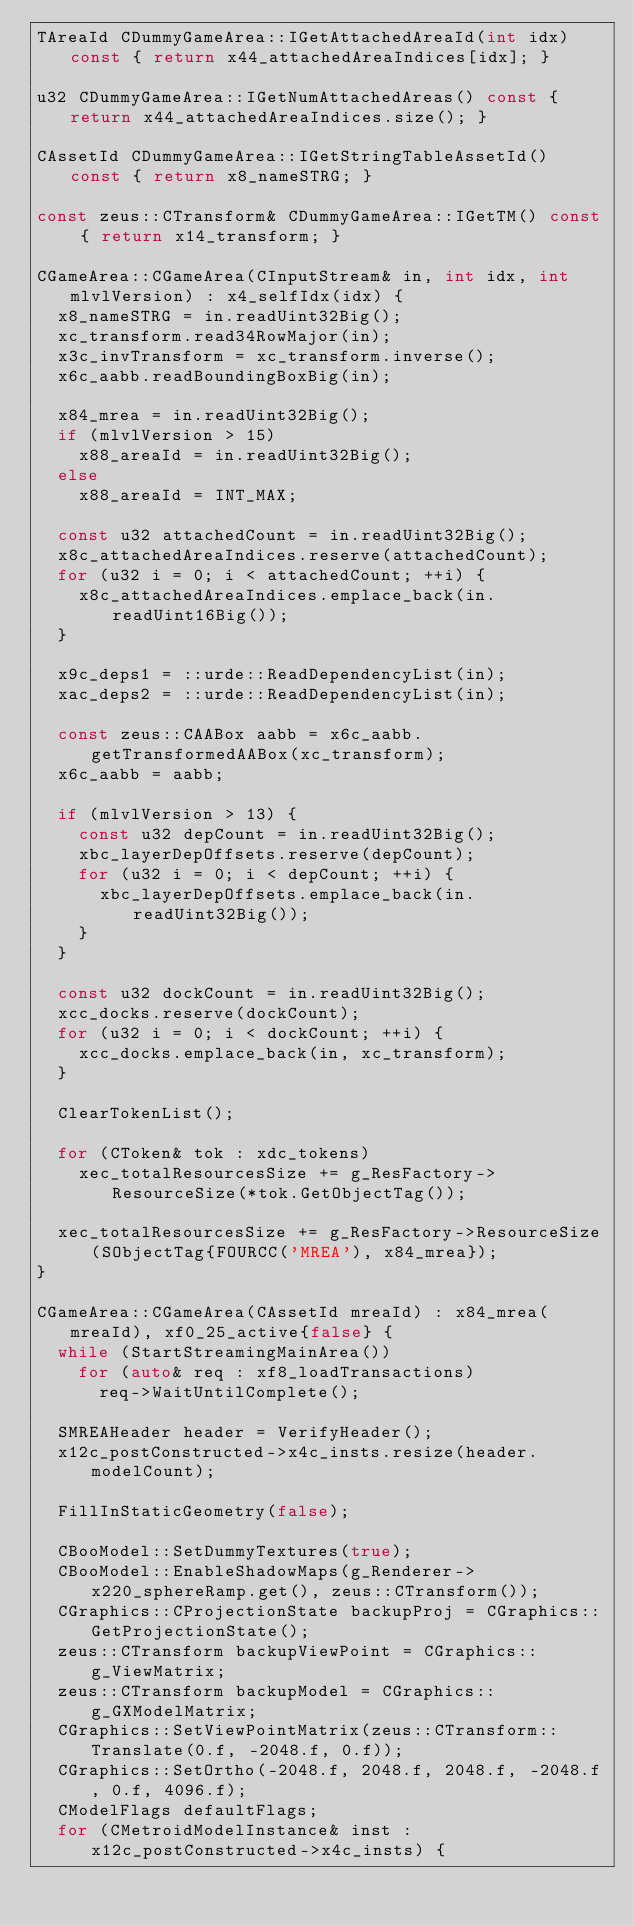Convert code to text. <code><loc_0><loc_0><loc_500><loc_500><_C++_>TAreaId CDummyGameArea::IGetAttachedAreaId(int idx) const { return x44_attachedAreaIndices[idx]; }

u32 CDummyGameArea::IGetNumAttachedAreas() const { return x44_attachedAreaIndices.size(); }

CAssetId CDummyGameArea::IGetStringTableAssetId() const { return x8_nameSTRG; }

const zeus::CTransform& CDummyGameArea::IGetTM() const { return x14_transform; }

CGameArea::CGameArea(CInputStream& in, int idx, int mlvlVersion) : x4_selfIdx(idx) {
  x8_nameSTRG = in.readUint32Big();
  xc_transform.read34RowMajor(in);
  x3c_invTransform = xc_transform.inverse();
  x6c_aabb.readBoundingBoxBig(in);

  x84_mrea = in.readUint32Big();
  if (mlvlVersion > 15)
    x88_areaId = in.readUint32Big();
  else
    x88_areaId = INT_MAX;

  const u32 attachedCount = in.readUint32Big();
  x8c_attachedAreaIndices.reserve(attachedCount);
  for (u32 i = 0; i < attachedCount; ++i) {
    x8c_attachedAreaIndices.emplace_back(in.readUint16Big());
  }

  x9c_deps1 = ::urde::ReadDependencyList(in);
  xac_deps2 = ::urde::ReadDependencyList(in);

  const zeus::CAABox aabb = x6c_aabb.getTransformedAABox(xc_transform);
  x6c_aabb = aabb;

  if (mlvlVersion > 13) {
    const u32 depCount = in.readUint32Big();
    xbc_layerDepOffsets.reserve(depCount);
    for (u32 i = 0; i < depCount; ++i) {
      xbc_layerDepOffsets.emplace_back(in.readUint32Big());
    }
  }

  const u32 dockCount = in.readUint32Big();
  xcc_docks.reserve(dockCount);
  for (u32 i = 0; i < dockCount; ++i) {
    xcc_docks.emplace_back(in, xc_transform);
  }

  ClearTokenList();

  for (CToken& tok : xdc_tokens)
    xec_totalResourcesSize += g_ResFactory->ResourceSize(*tok.GetObjectTag());

  xec_totalResourcesSize += g_ResFactory->ResourceSize(SObjectTag{FOURCC('MREA'), x84_mrea});
}

CGameArea::CGameArea(CAssetId mreaId) : x84_mrea(mreaId), xf0_25_active{false} {
  while (StartStreamingMainArea())
    for (auto& req : xf8_loadTransactions)
      req->WaitUntilComplete();

  SMREAHeader header = VerifyHeader();
  x12c_postConstructed->x4c_insts.resize(header.modelCount);

  FillInStaticGeometry(false);

  CBooModel::SetDummyTextures(true);
  CBooModel::EnableShadowMaps(g_Renderer->x220_sphereRamp.get(), zeus::CTransform());
  CGraphics::CProjectionState backupProj = CGraphics::GetProjectionState();
  zeus::CTransform backupViewPoint = CGraphics::g_ViewMatrix;
  zeus::CTransform backupModel = CGraphics::g_GXModelMatrix;
  CGraphics::SetViewPointMatrix(zeus::CTransform::Translate(0.f, -2048.f, 0.f));
  CGraphics::SetOrtho(-2048.f, 2048.f, 2048.f, -2048.f, 0.f, 4096.f);
  CModelFlags defaultFlags;
  for (CMetroidModelInstance& inst : x12c_postConstructed->x4c_insts) {</code> 